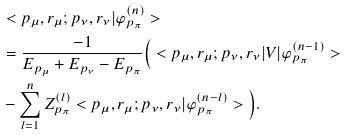Convert formula to latex. <formula><loc_0><loc_0><loc_500><loc_500>& < p _ { \mu } , r _ { \mu } ; p _ { \nu } , r _ { \nu } | \varphi _ { p _ { \pi } } ^ { ( n ) } > \\ & = \frac { - 1 } { E _ { p _ { \mu } } + E _ { p _ { \nu } } - E _ { p _ { \pi } } } \Big { ( } < p _ { \mu } , r _ { \mu } ; p _ { \nu } , r _ { \nu } | V | \varphi _ { p _ { \pi } } ^ { ( n - 1 ) } > \\ & - \sum _ { l = 1 } ^ { n } Z _ { p _ { \pi } } ^ { ( l ) } < p _ { \mu } , r _ { \mu } ; p _ { \nu } , r _ { \nu } | \varphi _ { p _ { \pi } } ^ { ( n - l ) } > \Big { ) } .</formula> 